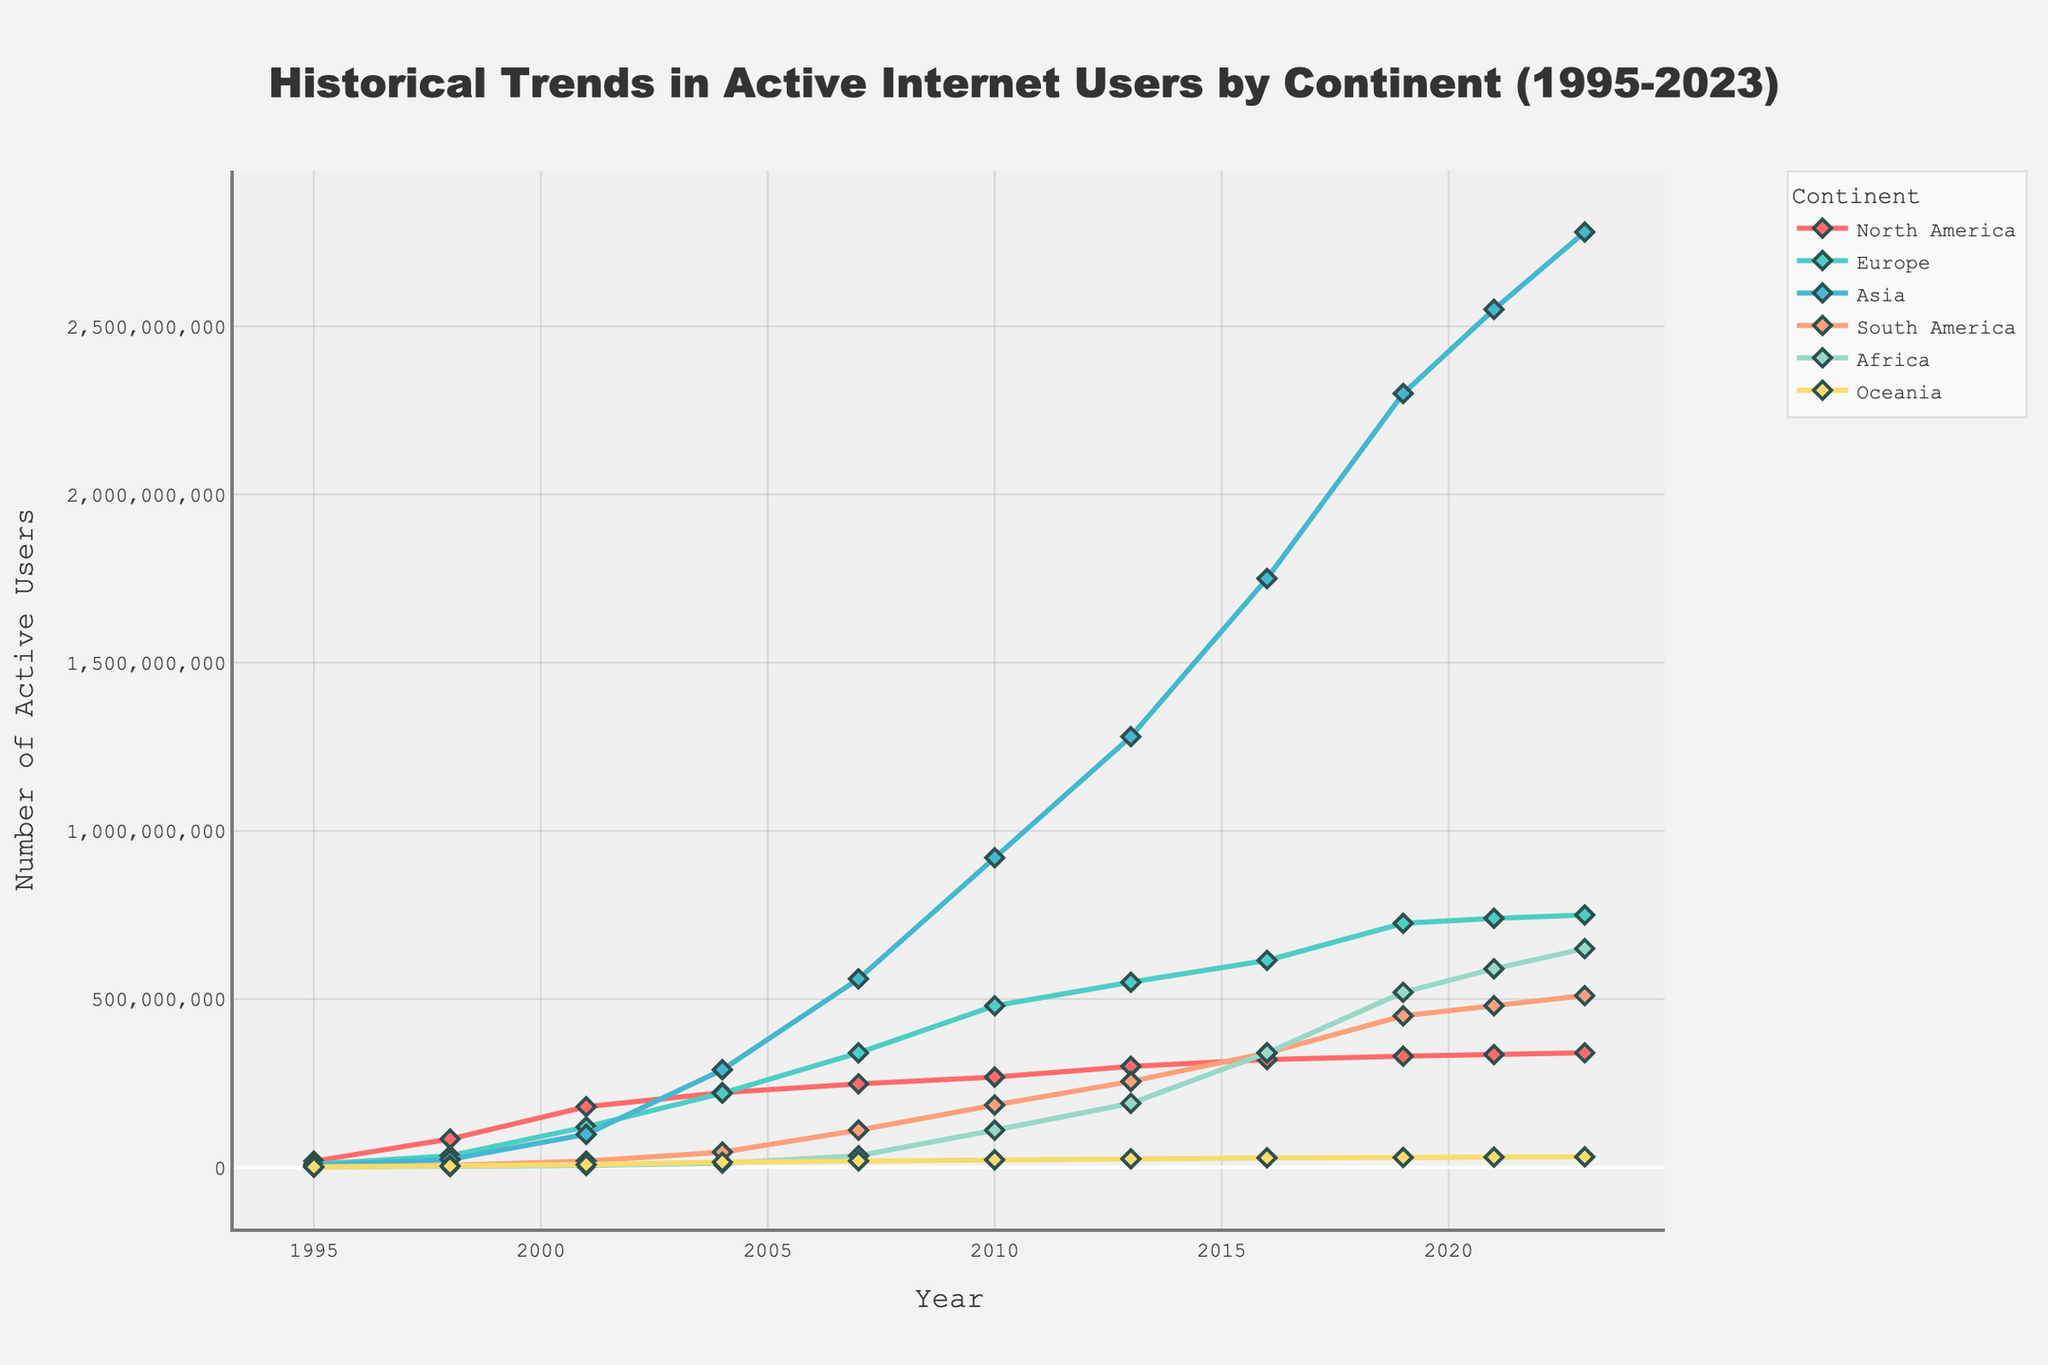What is the trend in the number of active internet users in Asia from 1995 to 2023? The graph shows a consistent increase in the number of users in Asia, which grew from about 5.5 million in 1995 to 2.78 billion in 2023.
Answer: Increasing Which continent had the highest number of active internet users in 2019? According to the chart, Asia had the highest number of active internet users in 2019 with 2.3 billion users.
Answer: Asia How did the number of active internet users in Africa change between 2010 and 2023? In 2010, Africa had approximately 110 million users. By 2023, the number increased to about 650 million, indicating substantial growth.
Answer: Increased Compare the number of active internet users in North America and Europe in 2004. Which continent had more users and by how many? In 2004, North America had about 222 million users while Europe had around 220 million. North America had 2 million more users than Europe.
Answer: North America by 2 million Identify the continent with the smallest number of active internet users in 1998. The chart shows that Africa had the smallest number of users in 1998, with approximately 2 million users.
Answer: Africa Calculate the total number of active internet users across all continents in 2023. To find the total, add the number of users from each continent: 340 million (North America) + 750 million (Europe) + 2.78 billion (Asia) + 510 million (South America) + 650 million (Africa) + 31 million (Oceania) = 5.061 billion.
Answer: 5.061 billion By how much did the number of active internet users in South America increase from 2007 to 2021? In 2007, South America had about 110 million users, and by 2021, this increased to approximately 480 million. The increase is 480 million - 110 million = 370 million.
Answer: 370 million Which continent had the fastest growth rate in the number of active internet users from 1995 to 2023? Asia had the fastest growth rate, increasing from 5.5 million in 1995 to 2.78 billion in 2023.
Answer: Asia 